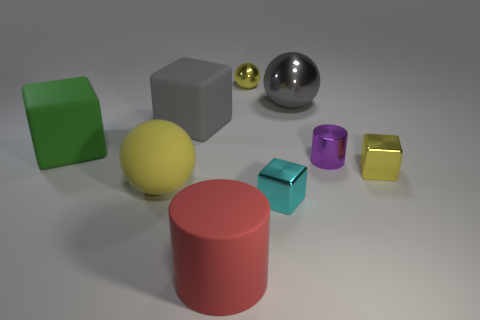Do the yellow rubber sphere and the cyan thing have the same size?
Give a very brief answer. No. How many things are yellow metal cubes or gray metallic balls that are to the right of the large red cylinder?
Provide a short and direct response. 2. What material is the large yellow object?
Your response must be concise. Rubber. Is there anything else that has the same color as the big cylinder?
Make the answer very short. No. Do the tiny cyan shiny object and the yellow rubber thing have the same shape?
Your answer should be very brief. No. What size is the rubber object that is on the left side of the large ball in front of the big gray thing on the left side of the yellow metal sphere?
Keep it short and to the point. Large. What number of other things are the same material as the cyan thing?
Give a very brief answer. 4. There is a small thing that is behind the large green cube; what color is it?
Offer a very short reply. Yellow. What is the tiny yellow object that is in front of the tiny yellow metallic thing behind the tiny yellow object that is in front of the purple metal cylinder made of?
Keep it short and to the point. Metal. Are there any other big yellow objects of the same shape as the big yellow matte object?
Offer a terse response. No. 